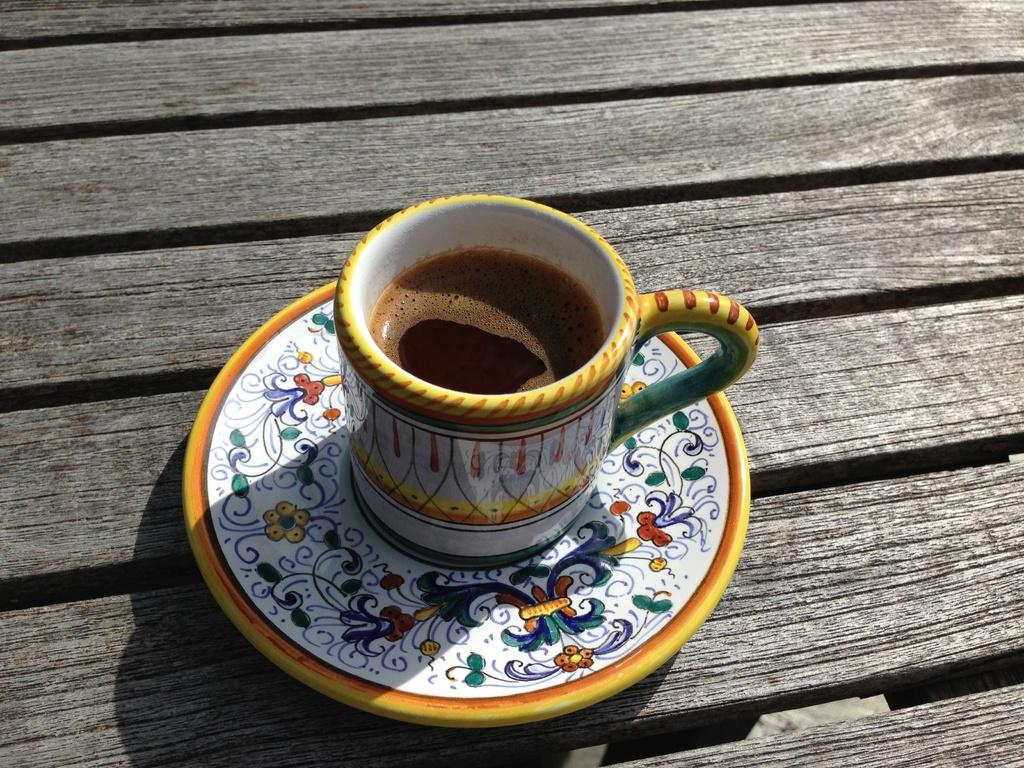What is on the table in the image? There is a plate on a table in the image. What is on the plate? There is a cup of coffee on the plate. What can be observed about the plate and cup? The plate and cup have designs. What type of pets are interacting with the dinosaurs in the image? There are no pets or dinosaurs present in the image; it only features a plate and a cup of coffee. 